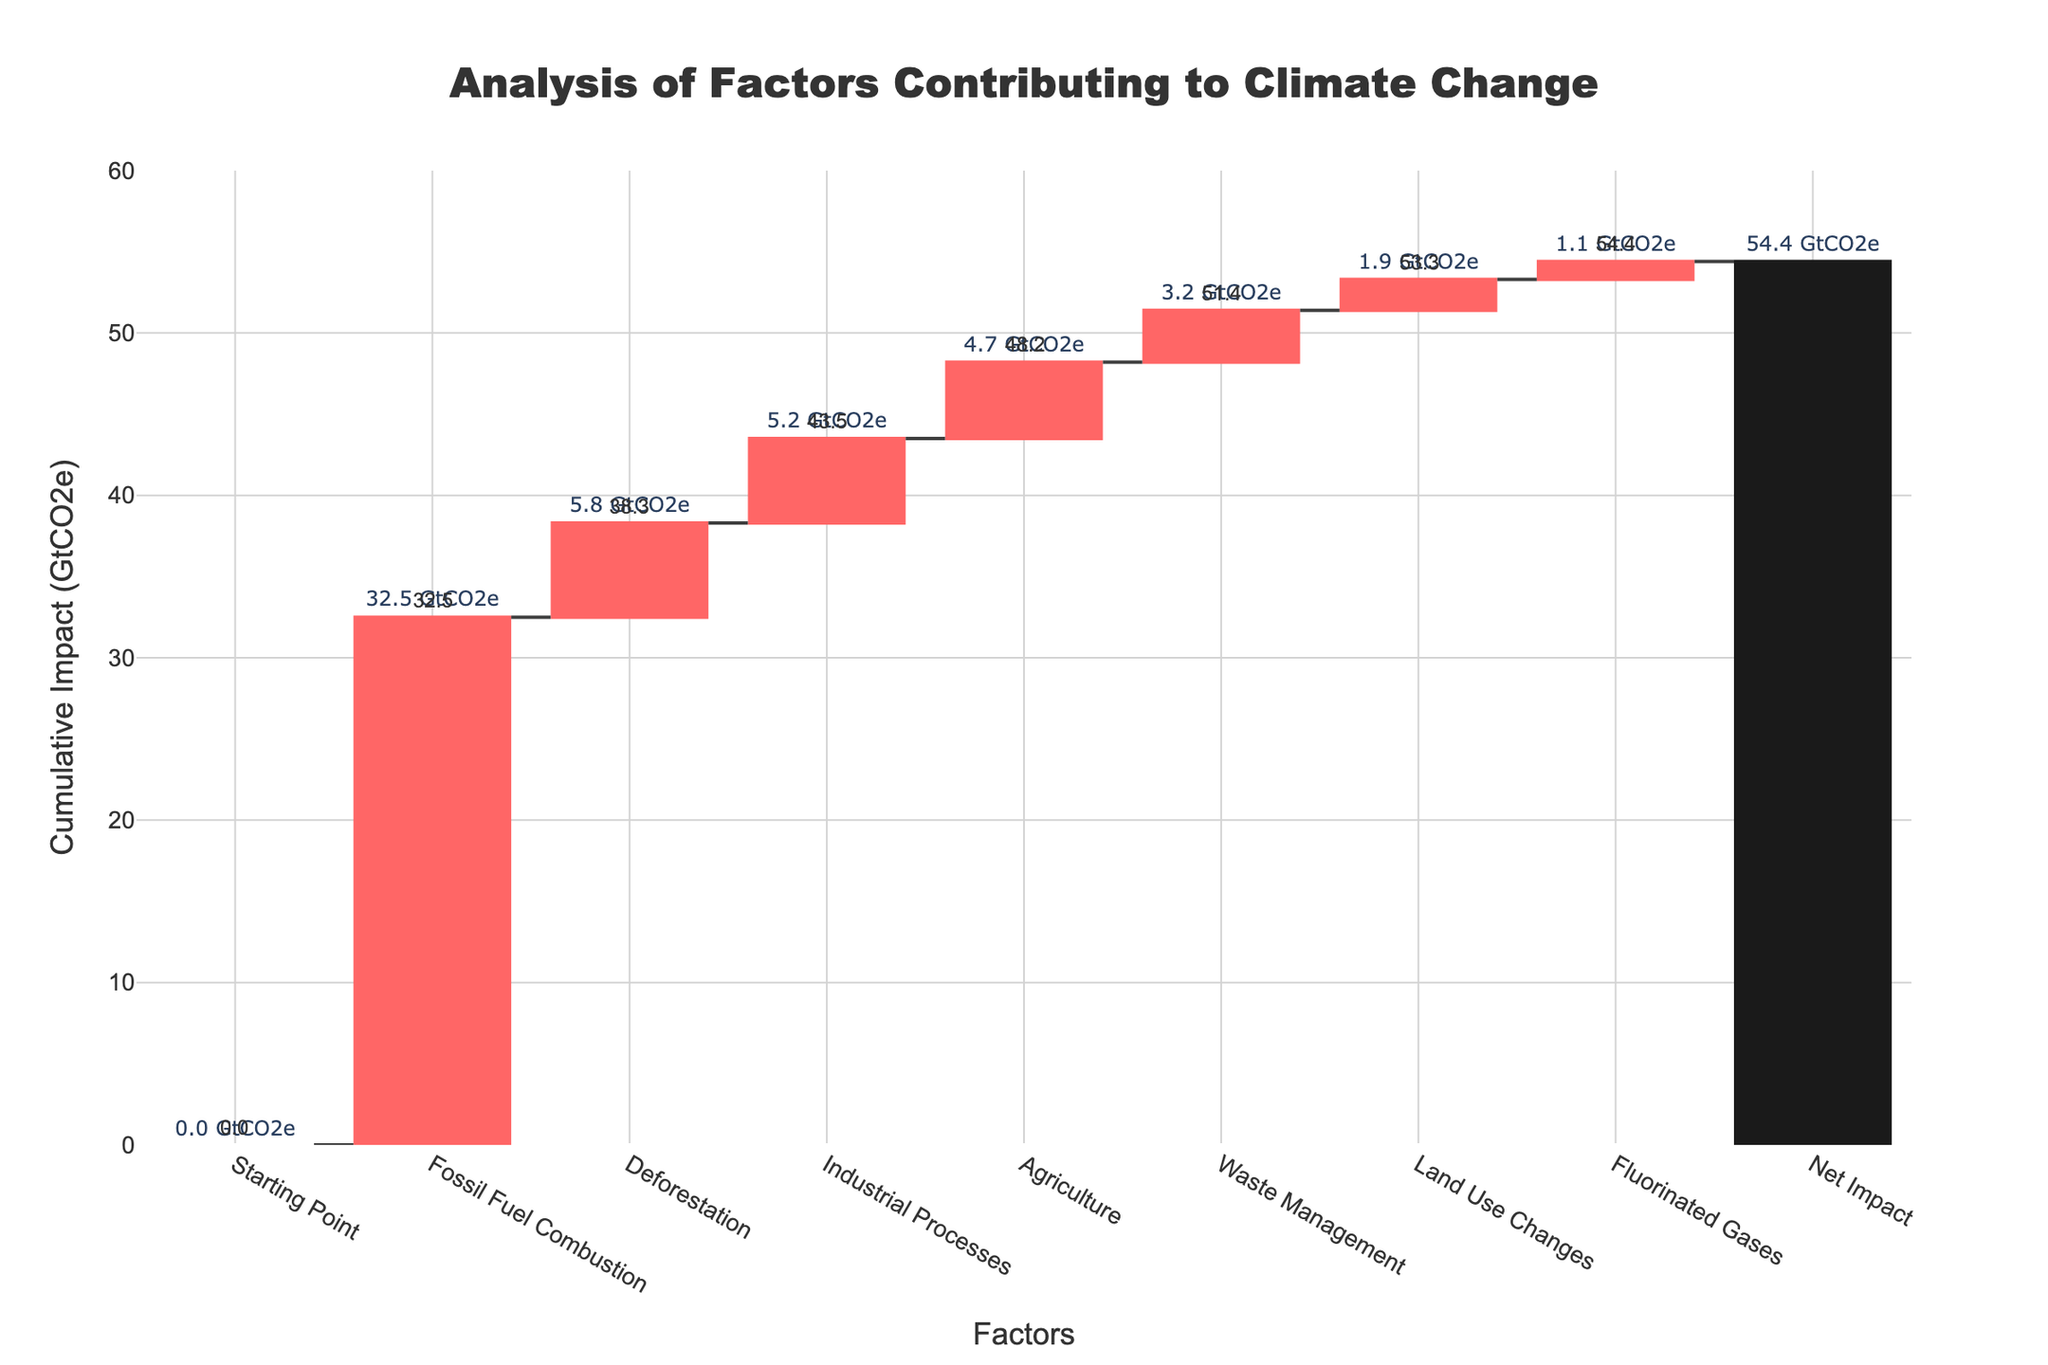What is the title of the plot? The title of the plot can be found at the top center of the figure. It reads "Analysis of Factors Contributing to Climate Change" in a large, bold font.
Answer: "Analysis of Factors Contributing to Climate Change" What is the combined impact of "Deforestation" and "Industrial Processes" in GtCO2e? First, find the values of "Deforestation" (5.8 GtCO2e) and "Industrial Processes" (5.2 GtCO2e). Add these two values together: 5.8 + 5.2 = 11.0 GtCO2e.
Answer: 11.0 GtCO2e By how much does "Fossil Fuel Combustion" exceed "Agriculture" in terms of impact? Find the impact values for "Fossil Fuel Combustion" (32.5 GtCO2e) and "Agriculture" (4.7 GtCO2e). Subtract the smaller from the larger value: 32.5 - 4.7 = 27.8 GtCO2e.
Answer: 27.8 GtCO2e Which category has the smallest impact on climate change, and what is its value? By inspecting the values on the chart, "Fluorinated Gases" has the smallest impact with a value of 1.1 GtCO2e.
Answer: Fluorinated Gases, 1.1 GtCO2e What is the cumulative impact shown at the endpoint "Net Impact" in GtCO2e? The cumulative impact at "Net Impact" is indicated in the figure, represented by the total sum of all preceding impacts. This value is 54.4 GtCO2e.
Answer: 54.4 GtCO2e How does the impact of "Waste Management" compare to "Land Use Changes"? Find the values for "Waste Management" (3.2 GtCO2e) and "Land Use Changes" (1.9 GtCO2e). Since 3.2 is greater than 1.9, "Waste Management" has a higher impact.
Answer: Waste Management has a higher impact If "Fossil Fuel Combustion" is removed, what would be the new cumulative impact? Without "Fossil Fuel Combustion," subtract its value (32.5 GtCO2e) from the total cumulative impact (54.4 GtCO2e): 54.4 - 32.5 = 21.9 GtCO2e.
Answer: 21.9 GtCO2e What percentage of the total impact is due to "Fossil Fuel Combustion"? The impact of "Fossil Fuel Combustion" is 32.5 GtCO2e, and the total impact is 54.4 GtCO2e. Calculate the percentage: (32.5 / 54.4) * 100 ≈ 59.74%.
Answer: 59.74% Which categories contribute more than 5 GtCO2e to the total impact? From the chart, identify categories with impacts greater than 5 GtCO2e: "Fossil Fuel Combustion" (32.5 GtCO2e), "Deforestation" (5.8 GtCO2e), and "Industrial Processes" (5.2 GtCO2e).
Answer: Fossil Fuel Combustion, Deforestation, Industrial Processes 